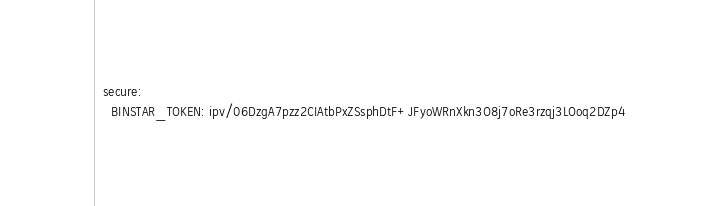<code> <loc_0><loc_0><loc_500><loc_500><_YAML_>  secure:
    BINSTAR_TOKEN: ipv/06DzgA7pzz2CIAtbPxZSsphDtF+JFyoWRnXkn3O8j7oRe3rzqj3LOoq2DZp4
</code> 